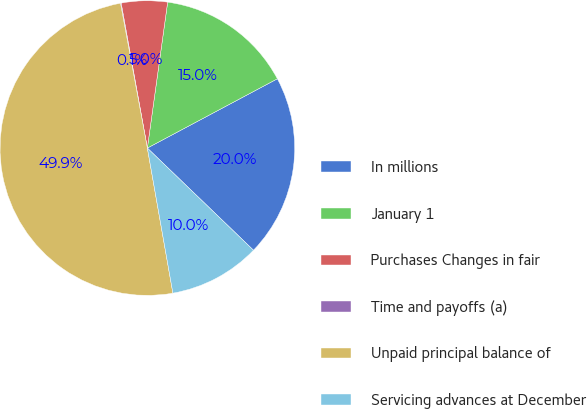Convert chart to OTSL. <chart><loc_0><loc_0><loc_500><loc_500><pie_chart><fcel>In millions<fcel>January 1<fcel>Purchases Changes in fair<fcel>Time and payoffs (a)<fcel>Unpaid principal balance of<fcel>Servicing advances at December<nl><fcel>19.99%<fcel>15.01%<fcel>5.05%<fcel>0.07%<fcel>49.86%<fcel>10.03%<nl></chart> 